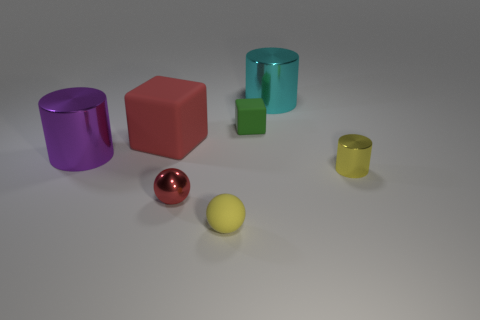Subtract all large metal cylinders. How many cylinders are left? 1 Subtract all yellow spheres. How many spheres are left? 1 Subtract all balls. How many objects are left? 5 Add 2 large blue metallic cylinders. How many objects exist? 9 Add 5 red objects. How many red objects exist? 7 Subtract 1 red cubes. How many objects are left? 6 Subtract all cyan spheres. Subtract all red blocks. How many spheres are left? 2 Subtract all purple metallic objects. Subtract all tiny red spheres. How many objects are left? 5 Add 2 spheres. How many spheres are left? 4 